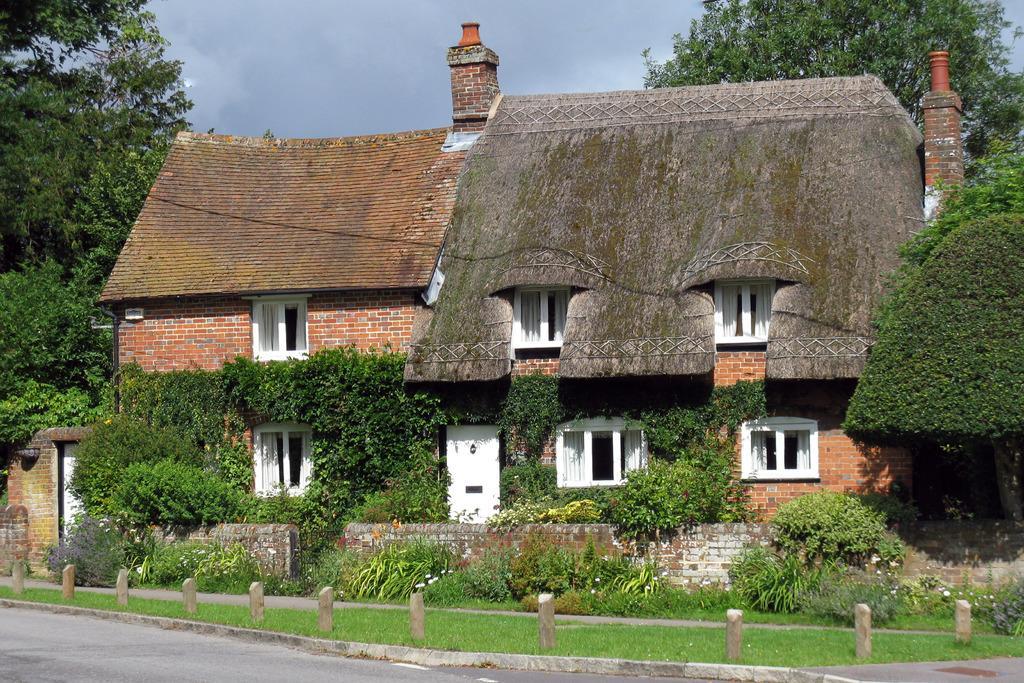Could you give a brief overview of what you see in this image? In the picture we can see a road and a grass surface and behind it, we can see some plants and a wall and behind it, we can see a house building with some creepers to the wall and besides the building we can see trees and behind the house we can see a sky with clouds. 